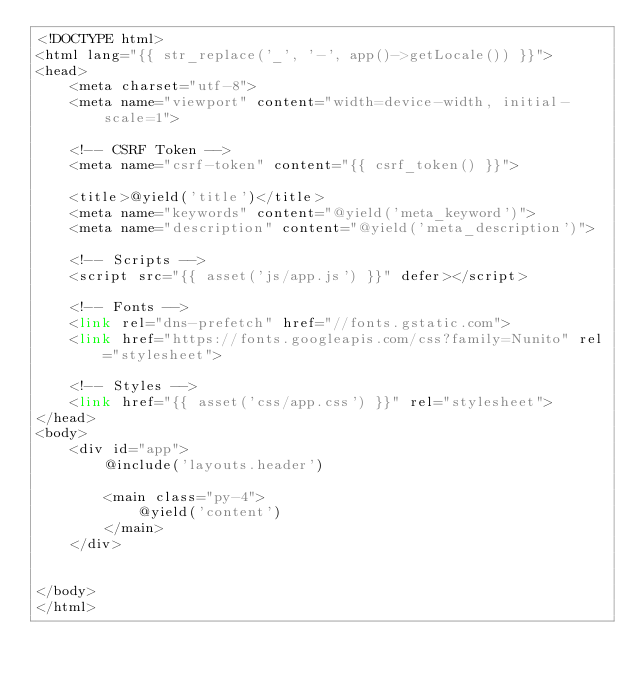Convert code to text. <code><loc_0><loc_0><loc_500><loc_500><_PHP_><!DOCTYPE html>
<html lang="{{ str_replace('_', '-', app()->getLocale()) }}">
<head>
    <meta charset="utf-8">
    <meta name="viewport" content="width=device-width, initial-scale=1">

    <!-- CSRF Token -->
    <meta name="csrf-token" content="{{ csrf_token() }}">

    <title>@yield('title')</title>
    <meta name="keywords" content="@yield('meta_keyword')">
    <meta name="description" content="@yield('meta_description')">

    <!-- Scripts -->
    <script src="{{ asset('js/app.js') }}" defer></script>

    <!-- Fonts -->
    <link rel="dns-prefetch" href="//fonts.gstatic.com">
    <link href="https://fonts.googleapis.com/css?family=Nunito" rel="stylesheet">

    <!-- Styles -->
    <link href="{{ asset('css/app.css') }}" rel="stylesheet">
</head>
<body>
    <div id="app">
        @include('layouts.header')

        <main class="py-4">
            @yield('content')
        </main>
    </div>


</body>
</html>
</code> 